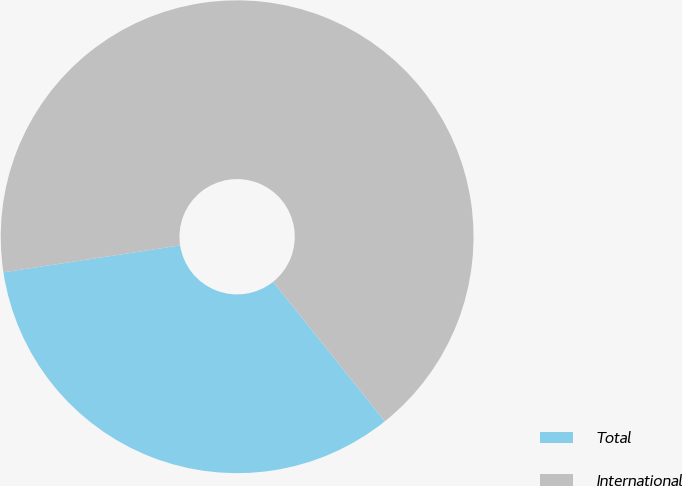Convert chart. <chart><loc_0><loc_0><loc_500><loc_500><pie_chart><fcel>Total<fcel>International<nl><fcel>33.33%<fcel>66.67%<nl></chart> 